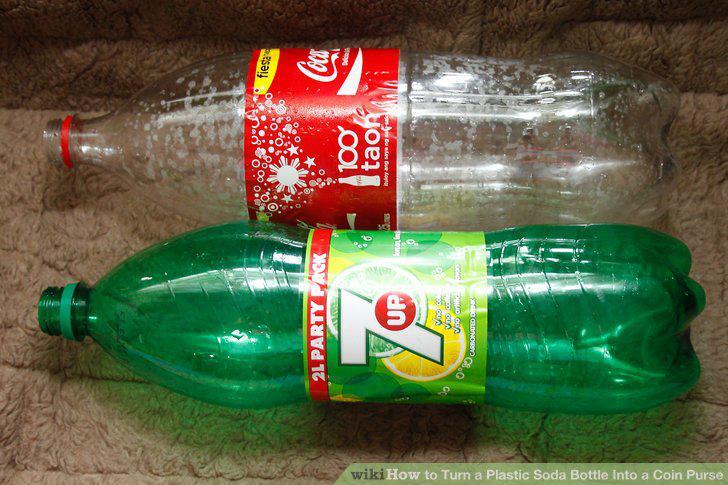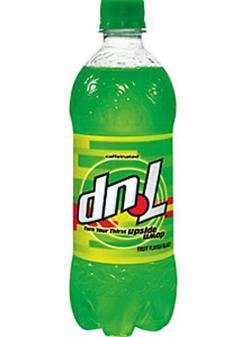The first image is the image on the left, the second image is the image on the right. For the images shown, is this caption "All of the soda bottles are green." true? Answer yes or no. No. The first image is the image on the left, the second image is the image on the right. Examine the images to the left and right. Is the description "There are two bottles total." accurate? Answer yes or no. No. 